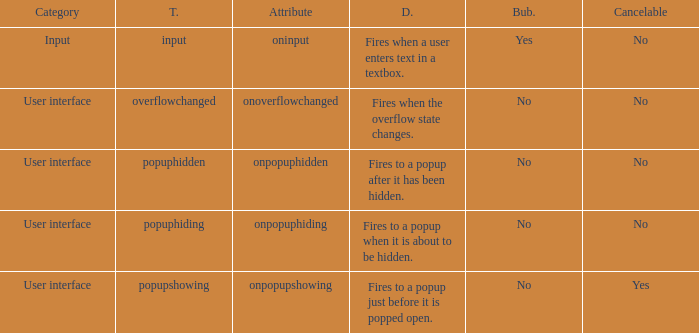Parse the full table. {'header': ['Category', 'T.', 'Attribute', 'D.', 'Bub.', 'Cancelable'], 'rows': [['Input', 'input', 'oninput', 'Fires when a user enters text in a textbox.', 'Yes', 'No'], ['User interface', 'overflowchanged', 'onoverflowchanged', 'Fires when the overflow state changes.', 'No', 'No'], ['User interface', 'popuphidden', 'onpopuphidden', 'Fires to a popup after it has been hidden.', 'No', 'No'], ['User interface', 'popuphiding', 'onpopuphiding', 'Fires to a popup when it is about to be hidden.', 'No', 'No'], ['User interface', 'popupshowing', 'onpopupshowing', 'Fires to a popup just before it is popped open.', 'No', 'Yes']]} What's the attribute with cancelable being yes Onpopupshowing. 